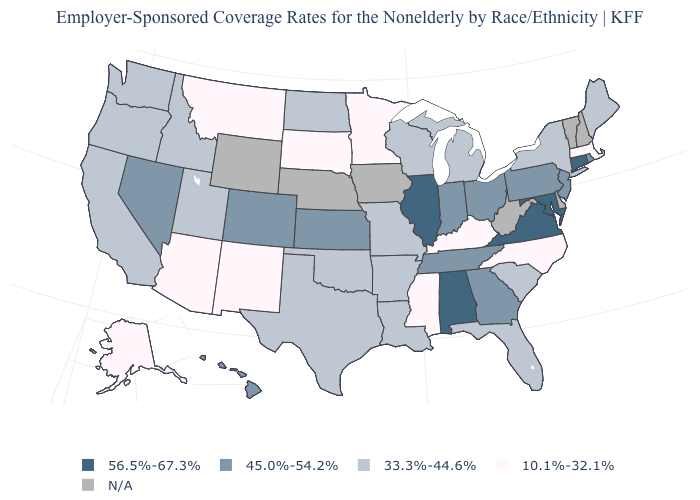What is the value of North Carolina?
Quick response, please. 10.1%-32.1%. What is the value of Nevada?
Give a very brief answer. 45.0%-54.2%. What is the value of Kansas?
Short answer required. 45.0%-54.2%. Is the legend a continuous bar?
Answer briefly. No. Which states hav the highest value in the West?
Write a very short answer. Colorado, Hawaii, Nevada. Does the map have missing data?
Keep it brief. Yes. Does Mississippi have the highest value in the USA?
Quick response, please. No. Name the states that have a value in the range 10.1%-32.1%?
Answer briefly. Alaska, Arizona, Kentucky, Massachusetts, Minnesota, Mississippi, Montana, New Mexico, North Carolina, South Dakota. Does Illinois have the highest value in the MidWest?
Keep it brief. Yes. What is the value of Louisiana?
Write a very short answer. 33.3%-44.6%. What is the value of New Hampshire?
Keep it brief. N/A. What is the highest value in the South ?
Write a very short answer. 56.5%-67.3%. Is the legend a continuous bar?
Concise answer only. No. Does North Dakota have the highest value in the USA?
Answer briefly. No. 